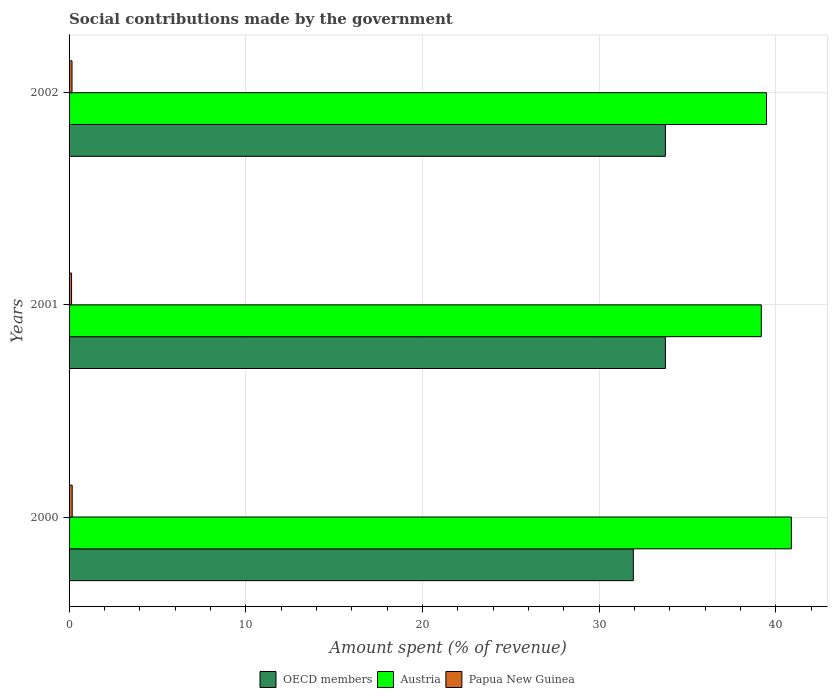How many different coloured bars are there?
Your answer should be very brief. 3. How many groups of bars are there?
Your answer should be very brief. 3. Are the number of bars on each tick of the Y-axis equal?
Keep it short and to the point. Yes. How many bars are there on the 1st tick from the top?
Your answer should be very brief. 3. How many bars are there on the 2nd tick from the bottom?
Offer a terse response. 3. In how many cases, is the number of bars for a given year not equal to the number of legend labels?
Your answer should be compact. 0. What is the amount spent (in %) on social contributions in Austria in 2001?
Your answer should be compact. 39.17. Across all years, what is the maximum amount spent (in %) on social contributions in OECD members?
Make the answer very short. 33.74. Across all years, what is the minimum amount spent (in %) on social contributions in Austria?
Make the answer very short. 39.17. In which year was the amount spent (in %) on social contributions in Austria maximum?
Your response must be concise. 2000. In which year was the amount spent (in %) on social contributions in Austria minimum?
Offer a very short reply. 2001. What is the total amount spent (in %) on social contributions in Papua New Guinea in the graph?
Your answer should be very brief. 0.48. What is the difference between the amount spent (in %) on social contributions in Austria in 2001 and that in 2002?
Offer a very short reply. -0.29. What is the difference between the amount spent (in %) on social contributions in OECD members in 2000 and the amount spent (in %) on social contributions in Papua New Guinea in 2001?
Ensure brevity in your answer.  31.79. What is the average amount spent (in %) on social contributions in Austria per year?
Provide a succinct answer. 39.83. In the year 2001, what is the difference between the amount spent (in %) on social contributions in Papua New Guinea and amount spent (in %) on social contributions in Austria?
Give a very brief answer. -39.03. In how many years, is the amount spent (in %) on social contributions in OECD members greater than 36 %?
Your response must be concise. 0. What is the ratio of the amount spent (in %) on social contributions in Austria in 2000 to that in 2002?
Your response must be concise. 1.04. What is the difference between the highest and the second highest amount spent (in %) on social contributions in Austria?
Your response must be concise. 1.41. What is the difference between the highest and the lowest amount spent (in %) on social contributions in OECD members?
Offer a very short reply. 1.82. Is the sum of the amount spent (in %) on social contributions in Papua New Guinea in 2000 and 2001 greater than the maximum amount spent (in %) on social contributions in Austria across all years?
Keep it short and to the point. No. What does the 1st bar from the bottom in 2002 represents?
Your response must be concise. OECD members. Is it the case that in every year, the sum of the amount spent (in %) on social contributions in Austria and amount spent (in %) on social contributions in OECD members is greater than the amount spent (in %) on social contributions in Papua New Guinea?
Provide a short and direct response. Yes. What is the difference between two consecutive major ticks on the X-axis?
Provide a succinct answer. 10. Are the values on the major ticks of X-axis written in scientific E-notation?
Ensure brevity in your answer.  No. Where does the legend appear in the graph?
Provide a succinct answer. Bottom center. How are the legend labels stacked?
Make the answer very short. Horizontal. What is the title of the graph?
Make the answer very short. Social contributions made by the government. Does "Andorra" appear as one of the legend labels in the graph?
Offer a terse response. No. What is the label or title of the X-axis?
Your answer should be very brief. Amount spent (% of revenue). What is the label or title of the Y-axis?
Provide a short and direct response. Years. What is the Amount spent (% of revenue) of OECD members in 2000?
Give a very brief answer. 31.93. What is the Amount spent (% of revenue) of Austria in 2000?
Make the answer very short. 40.87. What is the Amount spent (% of revenue) of Papua New Guinea in 2000?
Provide a succinct answer. 0.18. What is the Amount spent (% of revenue) in OECD members in 2001?
Offer a terse response. 33.74. What is the Amount spent (% of revenue) in Austria in 2001?
Keep it short and to the point. 39.17. What is the Amount spent (% of revenue) in Papua New Guinea in 2001?
Provide a short and direct response. 0.14. What is the Amount spent (% of revenue) in OECD members in 2002?
Make the answer very short. 33.74. What is the Amount spent (% of revenue) in Austria in 2002?
Your response must be concise. 39.46. What is the Amount spent (% of revenue) in Papua New Guinea in 2002?
Offer a terse response. 0.17. Across all years, what is the maximum Amount spent (% of revenue) in OECD members?
Provide a short and direct response. 33.74. Across all years, what is the maximum Amount spent (% of revenue) of Austria?
Your answer should be very brief. 40.87. Across all years, what is the maximum Amount spent (% of revenue) in Papua New Guinea?
Offer a very short reply. 0.18. Across all years, what is the minimum Amount spent (% of revenue) in OECD members?
Your response must be concise. 31.93. Across all years, what is the minimum Amount spent (% of revenue) of Austria?
Ensure brevity in your answer.  39.17. Across all years, what is the minimum Amount spent (% of revenue) in Papua New Guinea?
Offer a terse response. 0.14. What is the total Amount spent (% of revenue) of OECD members in the graph?
Ensure brevity in your answer.  99.41. What is the total Amount spent (% of revenue) of Austria in the graph?
Offer a terse response. 119.5. What is the total Amount spent (% of revenue) in Papua New Guinea in the graph?
Give a very brief answer. 0.48. What is the difference between the Amount spent (% of revenue) in OECD members in 2000 and that in 2001?
Provide a succinct answer. -1.81. What is the difference between the Amount spent (% of revenue) in Austria in 2000 and that in 2001?
Provide a succinct answer. 1.7. What is the difference between the Amount spent (% of revenue) of Papua New Guinea in 2000 and that in 2001?
Keep it short and to the point. 0.04. What is the difference between the Amount spent (% of revenue) in OECD members in 2000 and that in 2002?
Offer a very short reply. -1.82. What is the difference between the Amount spent (% of revenue) of Austria in 2000 and that in 2002?
Give a very brief answer. 1.41. What is the difference between the Amount spent (% of revenue) of Papua New Guinea in 2000 and that in 2002?
Your answer should be very brief. 0.01. What is the difference between the Amount spent (% of revenue) of OECD members in 2001 and that in 2002?
Offer a very short reply. -0. What is the difference between the Amount spent (% of revenue) of Austria in 2001 and that in 2002?
Offer a terse response. -0.29. What is the difference between the Amount spent (% of revenue) in Papua New Guinea in 2001 and that in 2002?
Offer a very short reply. -0.03. What is the difference between the Amount spent (% of revenue) in OECD members in 2000 and the Amount spent (% of revenue) in Austria in 2001?
Ensure brevity in your answer.  -7.24. What is the difference between the Amount spent (% of revenue) in OECD members in 2000 and the Amount spent (% of revenue) in Papua New Guinea in 2001?
Give a very brief answer. 31.79. What is the difference between the Amount spent (% of revenue) of Austria in 2000 and the Amount spent (% of revenue) of Papua New Guinea in 2001?
Give a very brief answer. 40.73. What is the difference between the Amount spent (% of revenue) of OECD members in 2000 and the Amount spent (% of revenue) of Austria in 2002?
Give a very brief answer. -7.54. What is the difference between the Amount spent (% of revenue) of OECD members in 2000 and the Amount spent (% of revenue) of Papua New Guinea in 2002?
Your answer should be compact. 31.76. What is the difference between the Amount spent (% of revenue) of Austria in 2000 and the Amount spent (% of revenue) of Papua New Guinea in 2002?
Your response must be concise. 40.7. What is the difference between the Amount spent (% of revenue) of OECD members in 2001 and the Amount spent (% of revenue) of Austria in 2002?
Your answer should be very brief. -5.72. What is the difference between the Amount spent (% of revenue) of OECD members in 2001 and the Amount spent (% of revenue) of Papua New Guinea in 2002?
Keep it short and to the point. 33.57. What is the difference between the Amount spent (% of revenue) of Austria in 2001 and the Amount spent (% of revenue) of Papua New Guinea in 2002?
Your answer should be very brief. 39. What is the average Amount spent (% of revenue) of OECD members per year?
Make the answer very short. 33.14. What is the average Amount spent (% of revenue) of Austria per year?
Make the answer very short. 39.84. What is the average Amount spent (% of revenue) of Papua New Guinea per year?
Provide a short and direct response. 0.16. In the year 2000, what is the difference between the Amount spent (% of revenue) in OECD members and Amount spent (% of revenue) in Austria?
Ensure brevity in your answer.  -8.94. In the year 2000, what is the difference between the Amount spent (% of revenue) in OECD members and Amount spent (% of revenue) in Papua New Guinea?
Your response must be concise. 31.75. In the year 2000, what is the difference between the Amount spent (% of revenue) in Austria and Amount spent (% of revenue) in Papua New Guinea?
Your answer should be compact. 40.69. In the year 2001, what is the difference between the Amount spent (% of revenue) in OECD members and Amount spent (% of revenue) in Austria?
Make the answer very short. -5.43. In the year 2001, what is the difference between the Amount spent (% of revenue) in OECD members and Amount spent (% of revenue) in Papua New Guinea?
Your response must be concise. 33.6. In the year 2001, what is the difference between the Amount spent (% of revenue) of Austria and Amount spent (% of revenue) of Papua New Guinea?
Your answer should be compact. 39.03. In the year 2002, what is the difference between the Amount spent (% of revenue) in OECD members and Amount spent (% of revenue) in Austria?
Give a very brief answer. -5.72. In the year 2002, what is the difference between the Amount spent (% of revenue) of OECD members and Amount spent (% of revenue) of Papua New Guinea?
Offer a very short reply. 33.58. In the year 2002, what is the difference between the Amount spent (% of revenue) in Austria and Amount spent (% of revenue) in Papua New Guinea?
Offer a very short reply. 39.3. What is the ratio of the Amount spent (% of revenue) in OECD members in 2000 to that in 2001?
Provide a short and direct response. 0.95. What is the ratio of the Amount spent (% of revenue) of Austria in 2000 to that in 2001?
Offer a very short reply. 1.04. What is the ratio of the Amount spent (% of revenue) of Papua New Guinea in 2000 to that in 2001?
Keep it short and to the point. 1.25. What is the ratio of the Amount spent (% of revenue) in OECD members in 2000 to that in 2002?
Keep it short and to the point. 0.95. What is the ratio of the Amount spent (% of revenue) in Austria in 2000 to that in 2002?
Ensure brevity in your answer.  1.04. What is the ratio of the Amount spent (% of revenue) of Papua New Guinea in 2000 to that in 2002?
Provide a succinct answer. 1.06. What is the ratio of the Amount spent (% of revenue) of Austria in 2001 to that in 2002?
Ensure brevity in your answer.  0.99. What is the ratio of the Amount spent (% of revenue) of Papua New Guinea in 2001 to that in 2002?
Keep it short and to the point. 0.85. What is the difference between the highest and the second highest Amount spent (% of revenue) in OECD members?
Keep it short and to the point. 0. What is the difference between the highest and the second highest Amount spent (% of revenue) of Austria?
Provide a short and direct response. 1.41. What is the difference between the highest and the second highest Amount spent (% of revenue) in Papua New Guinea?
Ensure brevity in your answer.  0.01. What is the difference between the highest and the lowest Amount spent (% of revenue) in OECD members?
Your answer should be very brief. 1.82. What is the difference between the highest and the lowest Amount spent (% of revenue) of Austria?
Keep it short and to the point. 1.7. What is the difference between the highest and the lowest Amount spent (% of revenue) of Papua New Guinea?
Your answer should be very brief. 0.04. 